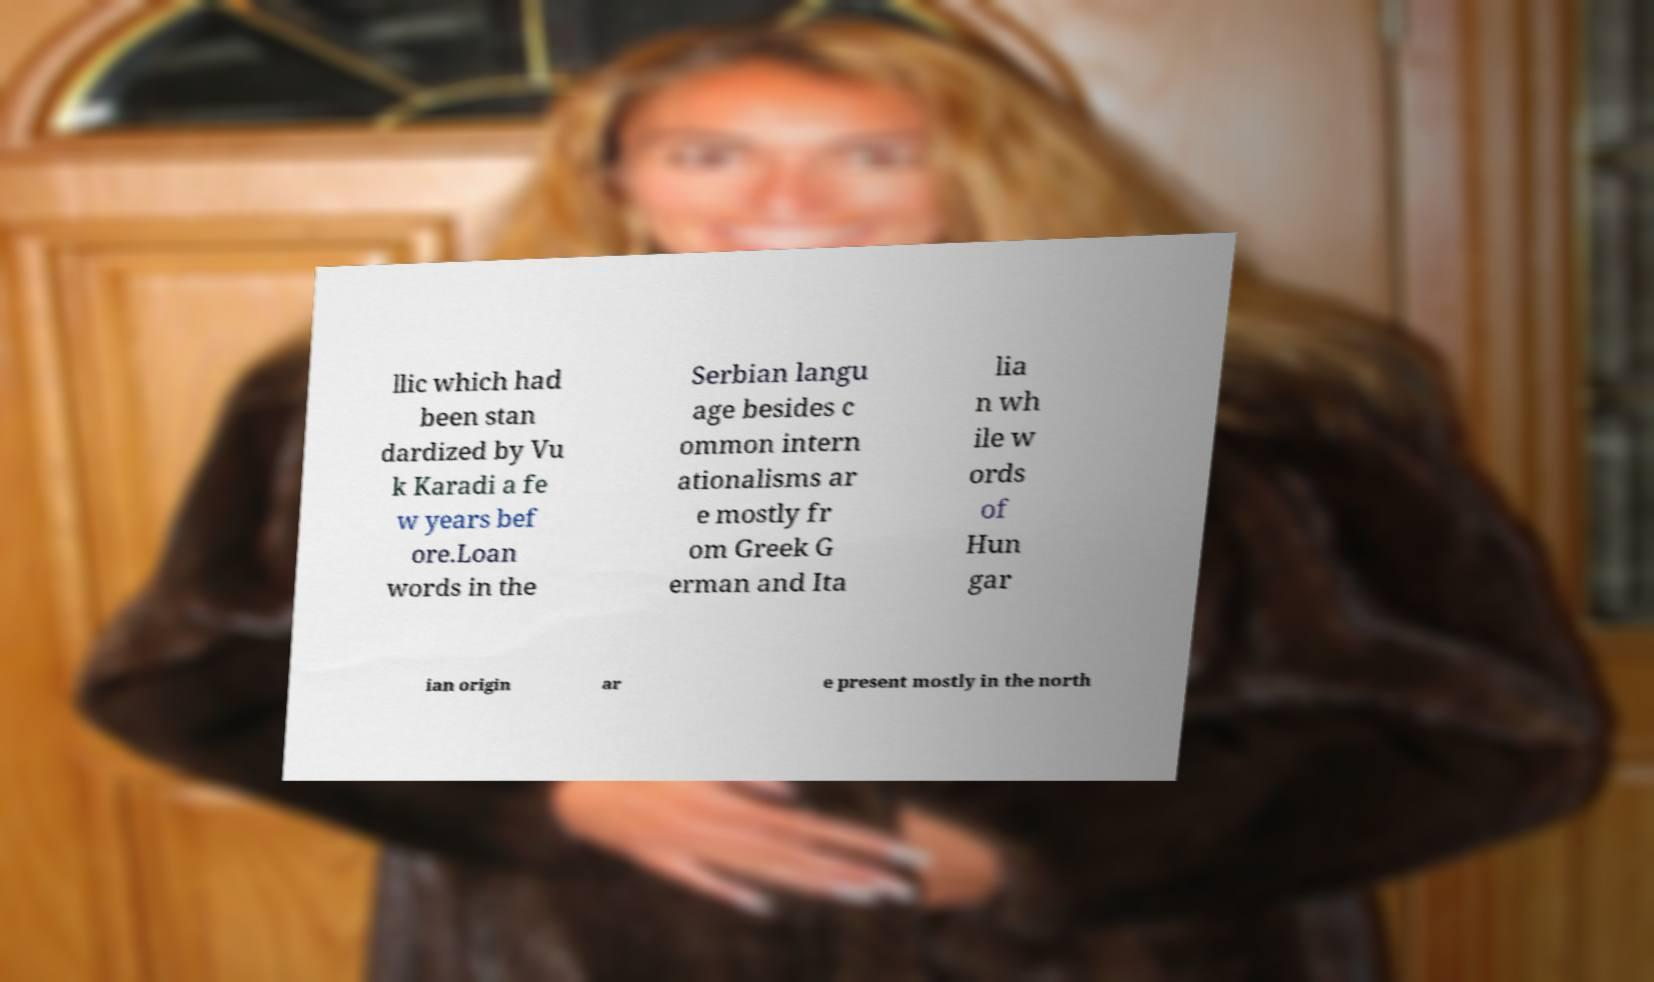Can you accurately transcribe the text from the provided image for me? llic which had been stan dardized by Vu k Karadi a fe w years bef ore.Loan words in the Serbian langu age besides c ommon intern ationalisms ar e mostly fr om Greek G erman and Ita lia n wh ile w ords of Hun gar ian origin ar e present mostly in the north 